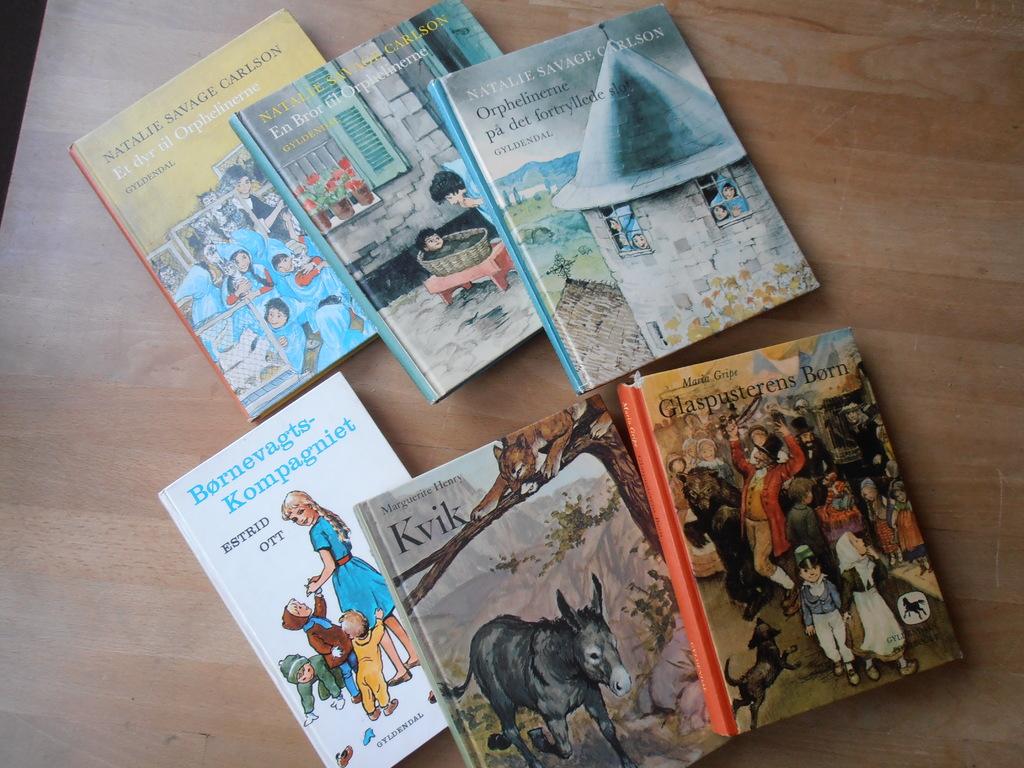What is the first letter in the title of the book with a donkey?
Keep it short and to the point. K. 